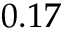Convert formula to latex. <formula><loc_0><loc_0><loc_500><loc_500>0 . 1 7</formula> 